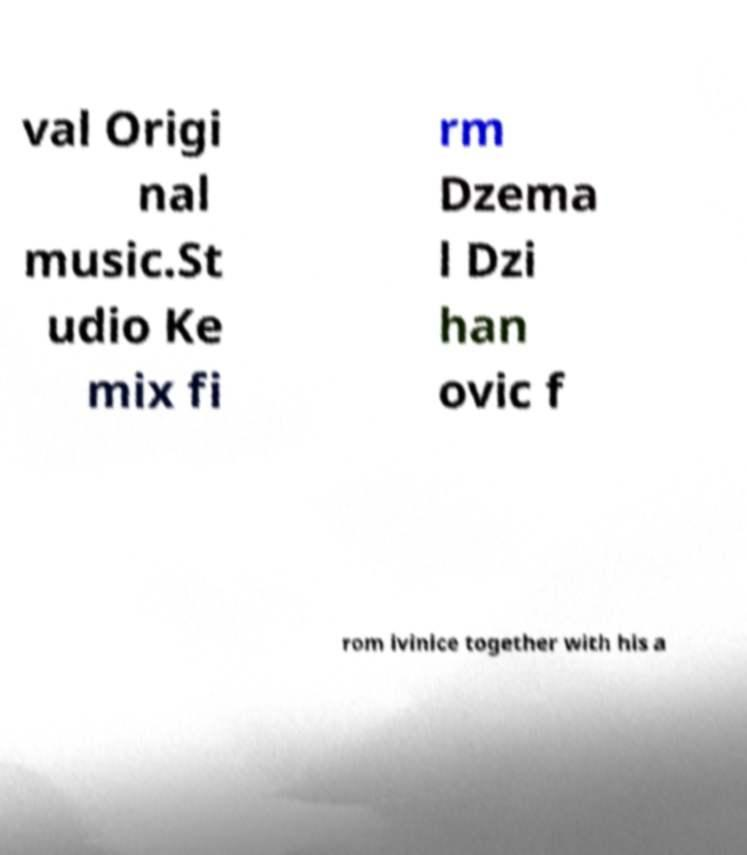I need the written content from this picture converted into text. Can you do that? val Origi nal music.St udio Ke mix fi rm Dzema l Dzi han ovic f rom ivinice together with his a 